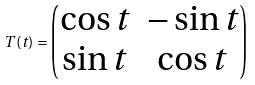Convert formula to latex. <formula><loc_0><loc_0><loc_500><loc_500>T ( t ) = \begin{pmatrix} \cos { t } & - \sin { t } \\ \sin { t } & \cos { t } \end{pmatrix}</formula> 